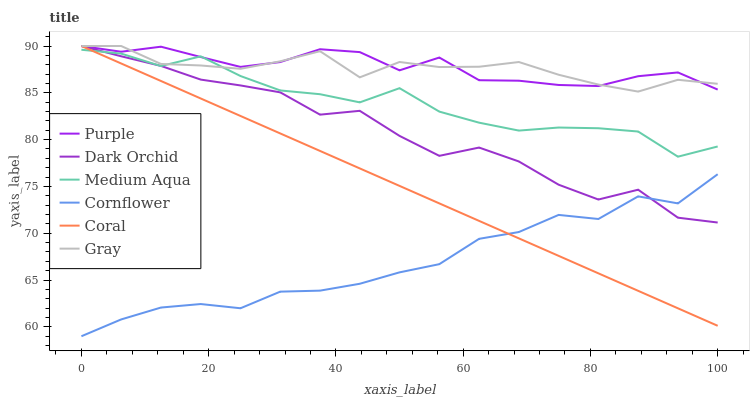Does Cornflower have the minimum area under the curve?
Answer yes or no. Yes. Does Purple have the maximum area under the curve?
Answer yes or no. Yes. Does Gray have the minimum area under the curve?
Answer yes or no. No. Does Gray have the maximum area under the curve?
Answer yes or no. No. Is Coral the smoothest?
Answer yes or no. Yes. Is Dark Orchid the roughest?
Answer yes or no. Yes. Is Gray the smoothest?
Answer yes or no. No. Is Gray the roughest?
Answer yes or no. No. Does Cornflower have the lowest value?
Answer yes or no. Yes. Does Gray have the lowest value?
Answer yes or no. No. Does Dark Orchid have the highest value?
Answer yes or no. Yes. Does Medium Aqua have the highest value?
Answer yes or no. No. Is Cornflower less than Medium Aqua?
Answer yes or no. Yes. Is Gray greater than Cornflower?
Answer yes or no. Yes. Does Gray intersect Coral?
Answer yes or no. Yes. Is Gray less than Coral?
Answer yes or no. No. Is Gray greater than Coral?
Answer yes or no. No. Does Cornflower intersect Medium Aqua?
Answer yes or no. No. 